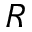Convert formula to latex. <formula><loc_0><loc_0><loc_500><loc_500>R</formula> 